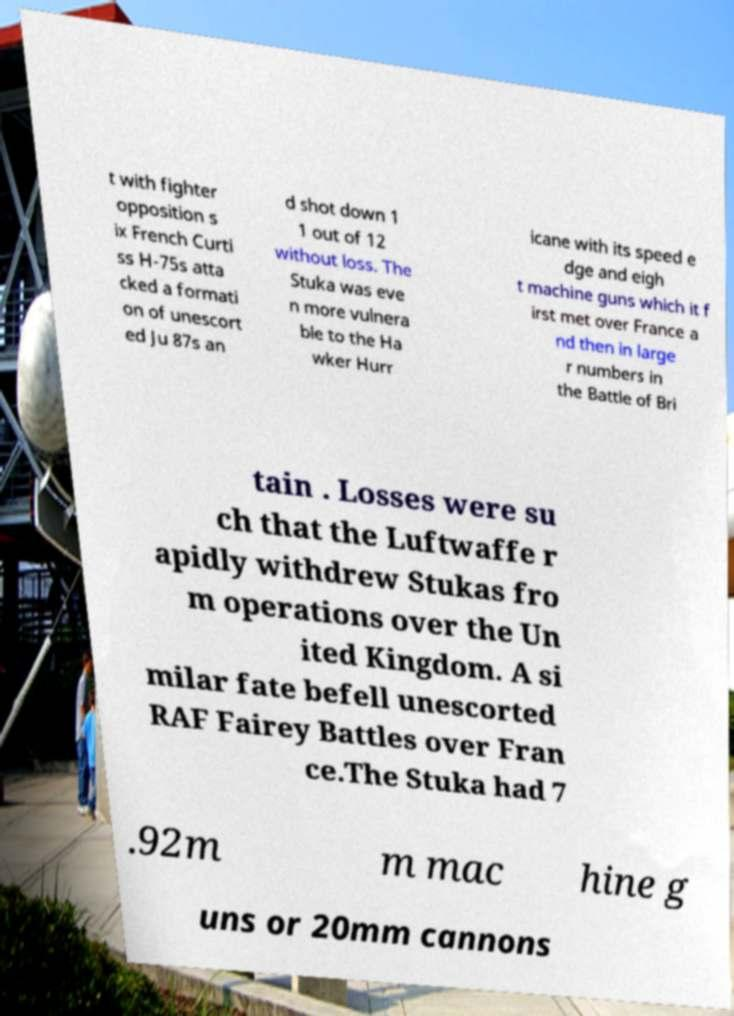Can you accurately transcribe the text from the provided image for me? t with fighter opposition s ix French Curti ss H-75s atta cked a formati on of unescort ed Ju 87s an d shot down 1 1 out of 12 without loss. The Stuka was eve n more vulnera ble to the Ha wker Hurr icane with its speed e dge and eigh t machine guns which it f irst met over France a nd then in large r numbers in the Battle of Bri tain . Losses were su ch that the Luftwaffe r apidly withdrew Stukas fro m operations over the Un ited Kingdom. A si milar fate befell unescorted RAF Fairey Battles over Fran ce.The Stuka had 7 .92m m mac hine g uns or 20mm cannons 